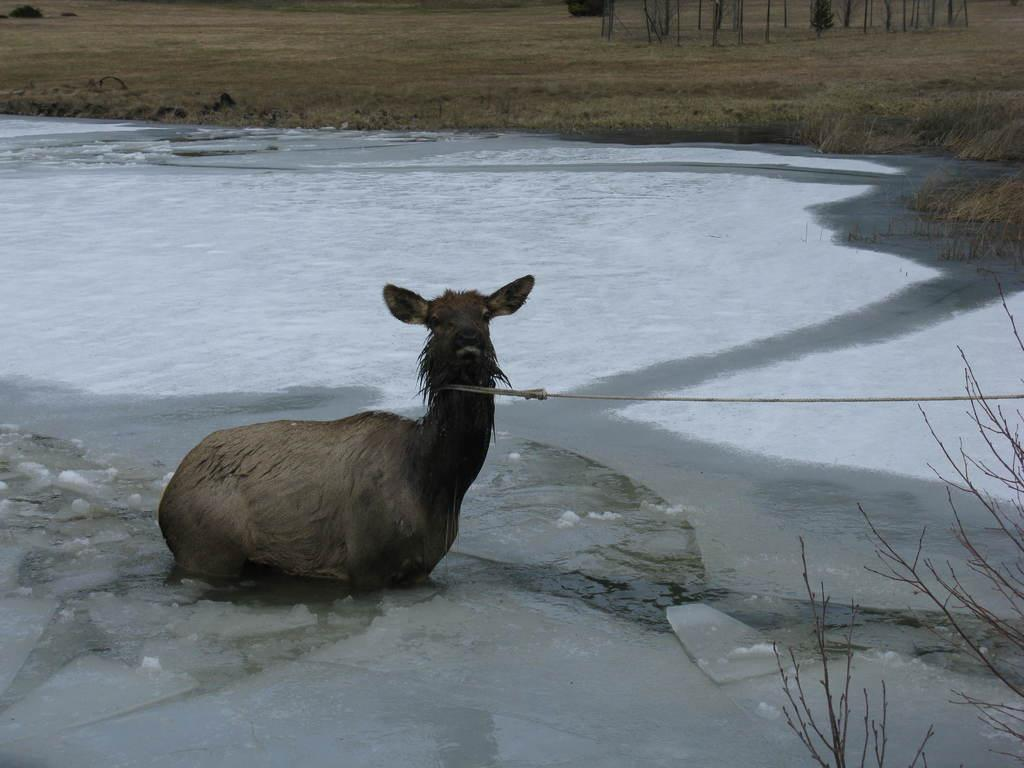What is the animal sitting on the ground in the image? The animal's specific type is not mentioned, but it is sitting on the ground in the image. What can be seen on the right side of the image? There is a tree on the right side of the image. What is visible in the background of the image? Water, grass, and trees are visible in the background of the image. How many pigs are swimming in the lake in the image? There is no lake or pigs present in the image. What type of insect can be seen crawling on the animal in the image? There is no insect visible on the animal in the image. 